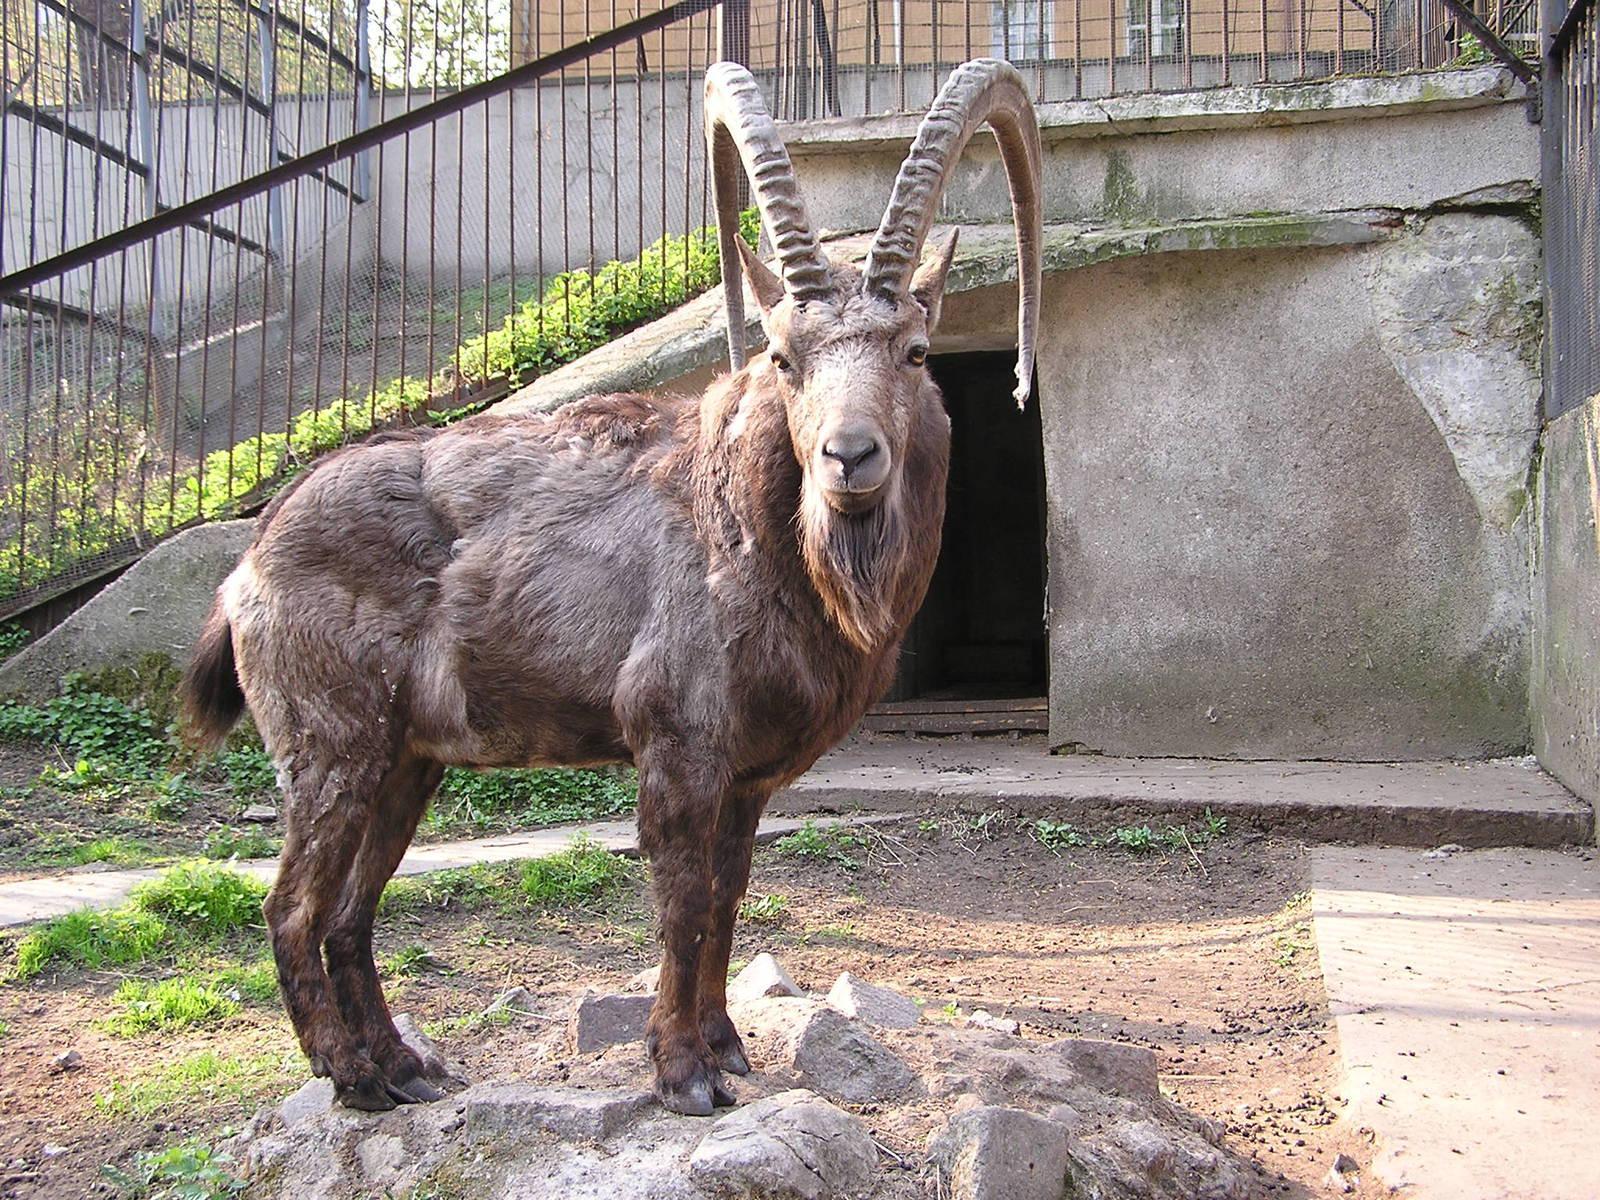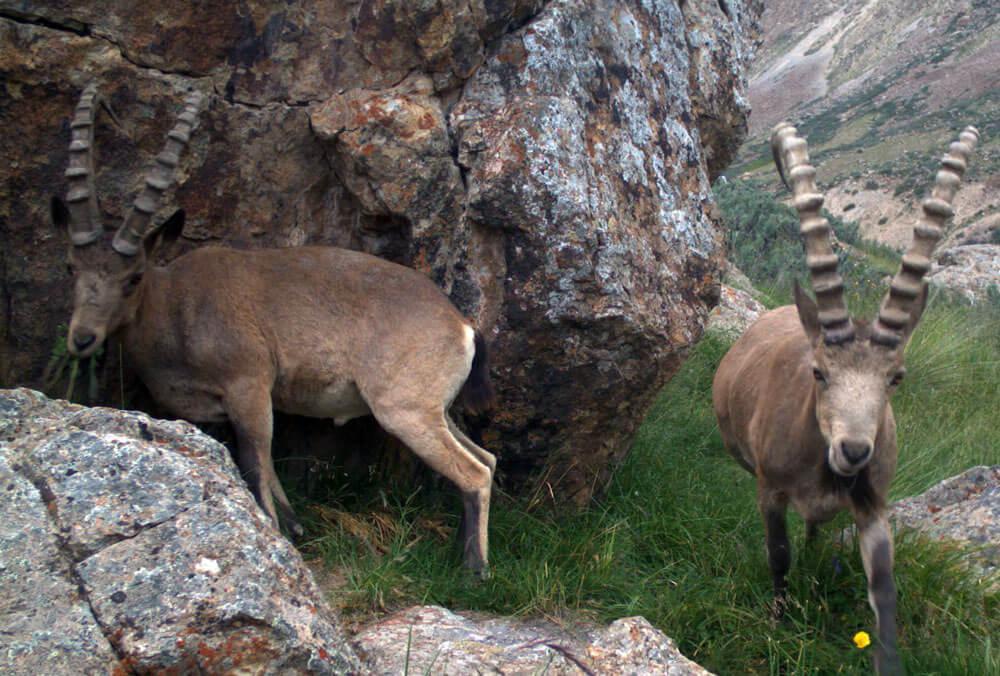The first image is the image on the left, the second image is the image on the right. For the images displayed, is the sentence "At least one image shows a horned animal resting on the ground with feet visible, tucked underneath." factually correct? Answer yes or no. No. 